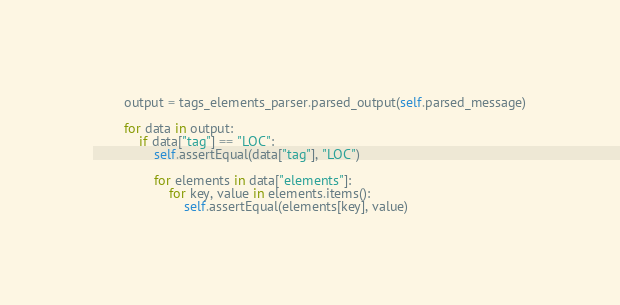Convert code to text. <code><loc_0><loc_0><loc_500><loc_500><_Python_>        output = tags_elements_parser.parsed_output(self.parsed_message)

        for data in output:
            if data["tag"] == "LOC":
                self.assertEqual(data["tag"], "LOC")

                for elements in data["elements"]:
                    for key, value in elements.items():
                        self.assertEqual(elements[key], value)
</code> 